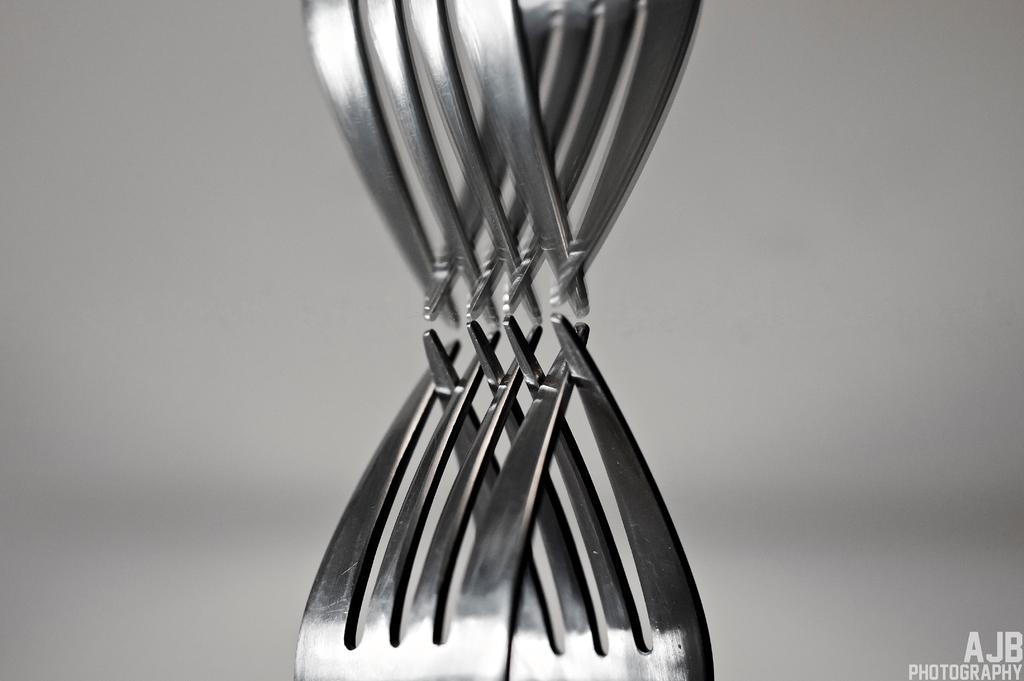How many forks can be seen in the image? There are two forks in the image. What can be observed about the forks in the image? The reflections of the forks are visible in the image. What type of feather can be seen on the fork in the image? There are no feathers present in the image; it only features two forks and their reflections. 